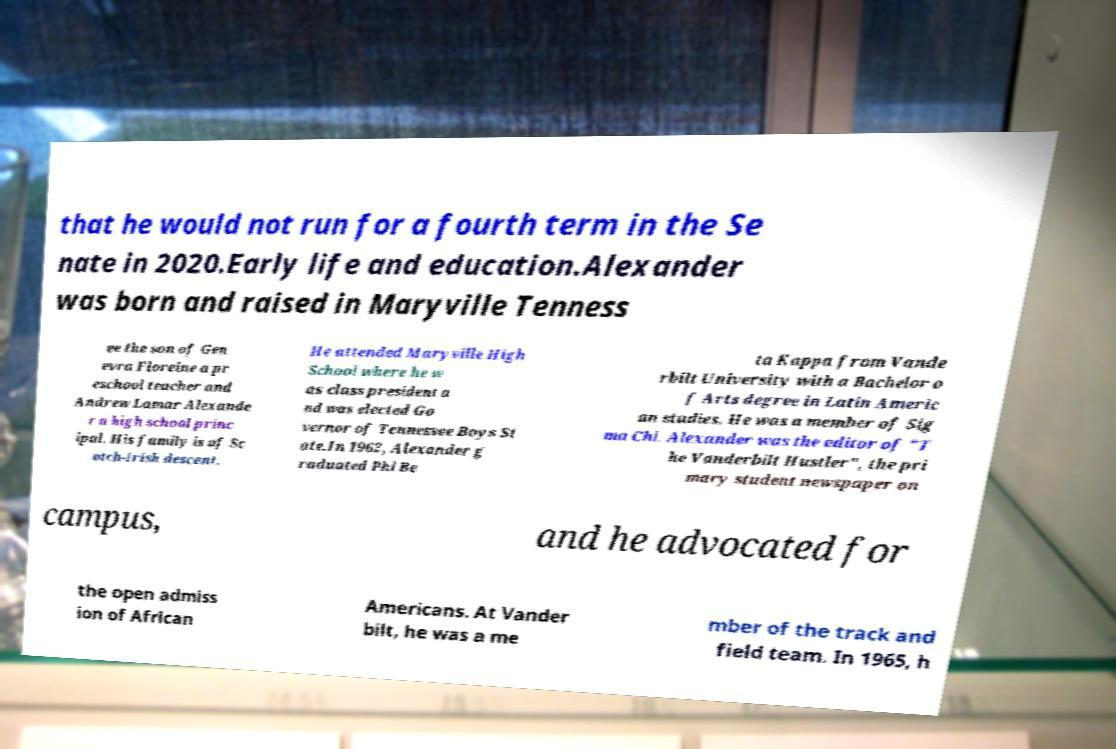Could you extract and type out the text from this image? that he would not run for a fourth term in the Se nate in 2020.Early life and education.Alexander was born and raised in Maryville Tenness ee the son of Gen evra Floreine a pr eschool teacher and Andrew Lamar Alexande r a high school princ ipal. His family is of Sc otch-Irish descent. He attended Maryville High School where he w as class president a nd was elected Go vernor of Tennessee Boys St ate.In 1962, Alexander g raduated Phi Be ta Kappa from Vande rbilt University with a Bachelor o f Arts degree in Latin Americ an studies. He was a member of Sig ma Chi. Alexander was the editor of "T he Vanderbilt Hustler", the pri mary student newspaper on campus, and he advocated for the open admiss ion of African Americans. At Vander bilt, he was a me mber of the track and field team. In 1965, h 